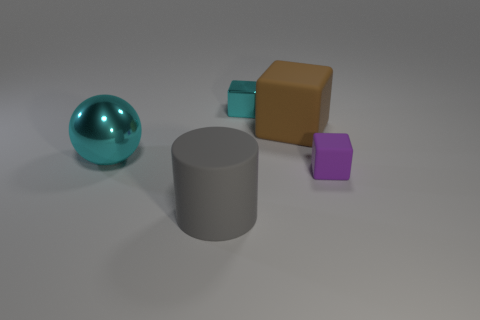Is the color of the large metallic ball the same as the metallic block?
Offer a very short reply. Yes. What number of things are large cyan objects or tiny cubes that are behind the small matte object?
Offer a terse response. 2. How many other things are there of the same shape as the purple matte thing?
Your answer should be very brief. 2. Is the number of small blocks behind the large sphere less than the number of small cubes to the right of the big matte cylinder?
Ensure brevity in your answer.  Yes. There is a big brown object that is made of the same material as the small purple cube; what is its shape?
Your answer should be very brief. Cube. Are there any other things of the same color as the tiny metal thing?
Your answer should be very brief. Yes. The large object to the right of the shiny thing on the right side of the sphere is what color?
Provide a succinct answer. Brown. What is the material of the small cube that is in front of the shiny object that is in front of the small block behind the tiny matte object?
Make the answer very short. Rubber. What number of shiny cubes have the same size as the purple matte cube?
Your answer should be compact. 1. There is a large object that is behind the matte cylinder and to the left of the big brown rubber object; what material is it?
Provide a short and direct response. Metal. 